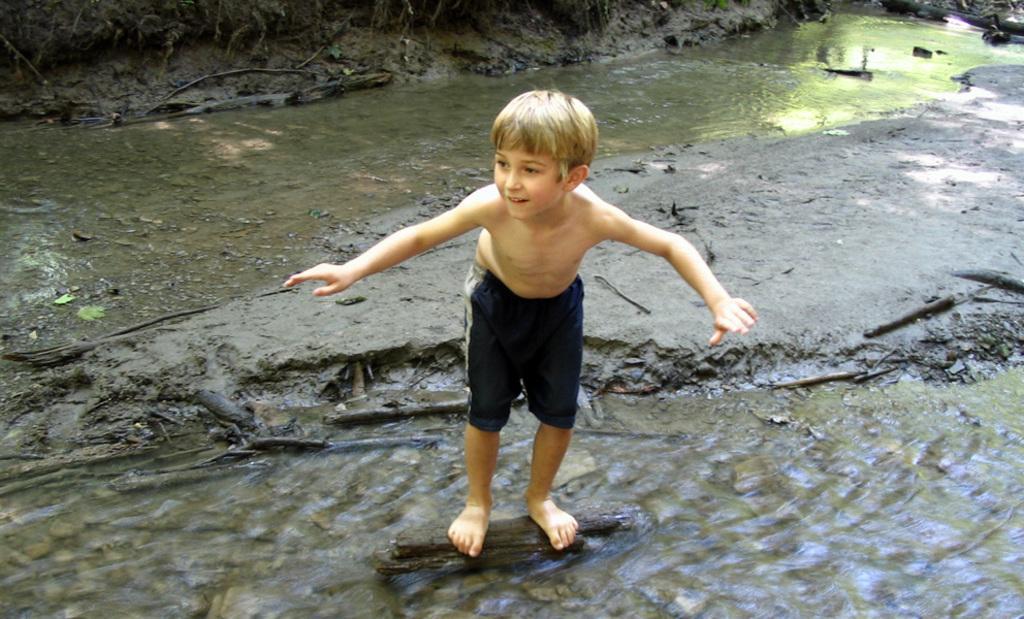Could you give a brief overview of what you see in this image? In this picture there is a small boy who is standing on the log and there is water at the top and bottom side of the image, there is a rock in the center of the image. 